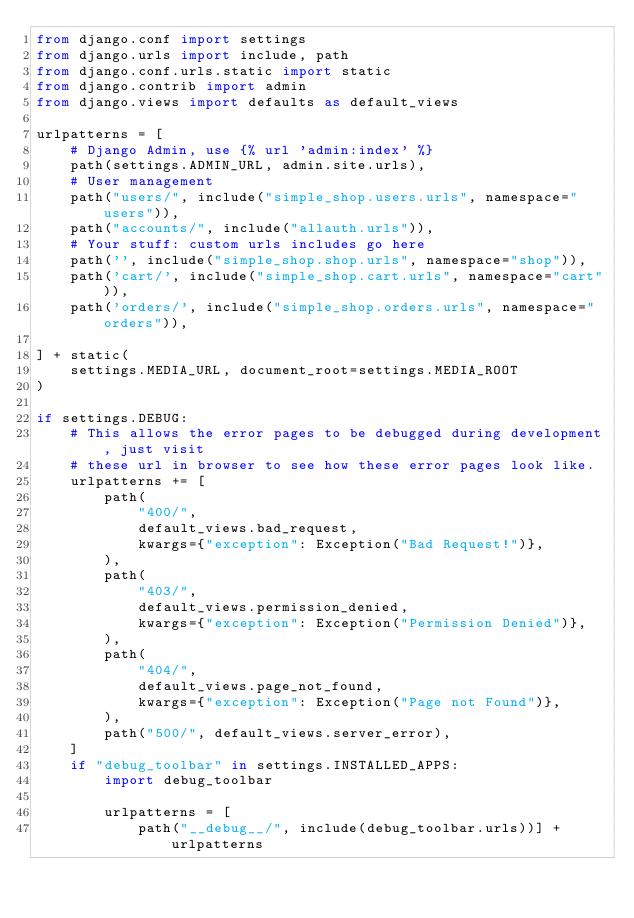Convert code to text. <code><loc_0><loc_0><loc_500><loc_500><_Python_>from django.conf import settings
from django.urls import include, path
from django.conf.urls.static import static
from django.contrib import admin
from django.views import defaults as default_views

urlpatterns = [
    # Django Admin, use {% url 'admin:index' %}
    path(settings.ADMIN_URL, admin.site.urls),
    # User management
    path("users/", include("simple_shop.users.urls", namespace="users")),
    path("accounts/", include("allauth.urls")),
    # Your stuff: custom urls includes go here
    path('', include("simple_shop.shop.urls", namespace="shop")),
    path('cart/', include("simple_shop.cart.urls", namespace="cart")),
    path('orders/', include("simple_shop.orders.urls", namespace="orders")),

] + static(
    settings.MEDIA_URL, document_root=settings.MEDIA_ROOT
)

if settings.DEBUG:
    # This allows the error pages to be debugged during development, just visit
    # these url in browser to see how these error pages look like.
    urlpatterns += [
        path(
            "400/",
            default_views.bad_request,
            kwargs={"exception": Exception("Bad Request!")},
        ),
        path(
            "403/",
            default_views.permission_denied,
            kwargs={"exception": Exception("Permission Denied")},
        ),
        path(
            "404/",
            default_views.page_not_found,
            kwargs={"exception": Exception("Page not Found")},
        ),
        path("500/", default_views.server_error),
    ]
    if "debug_toolbar" in settings.INSTALLED_APPS:
        import debug_toolbar

        urlpatterns = [
            path("__debug__/", include(debug_toolbar.urls))] + urlpatterns
</code> 